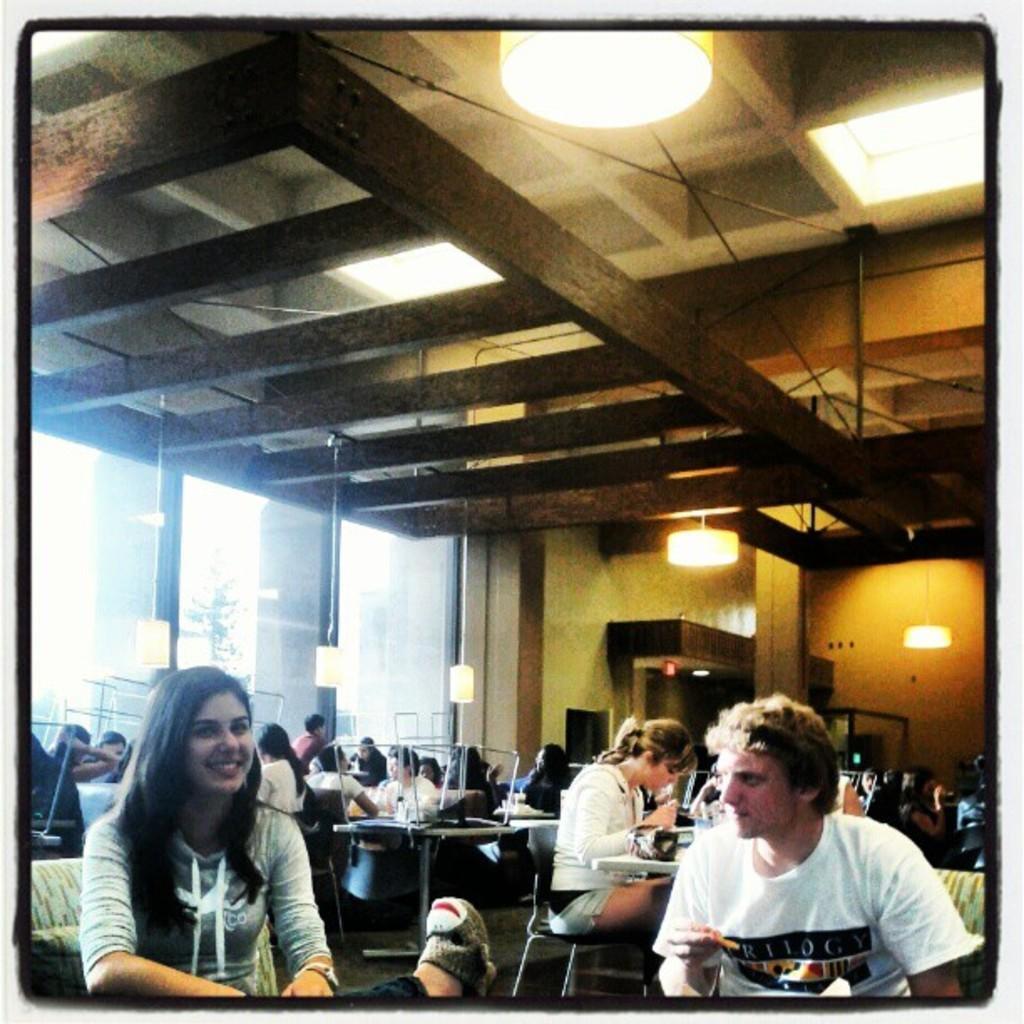Please provide a concise description of this image. I can see in this image a group of people are sitting on the chair in front of a table. In the front I can see a woman and man are sitting together, the woman is smiling in the background. I can see a wall, a light it and ceiling. 